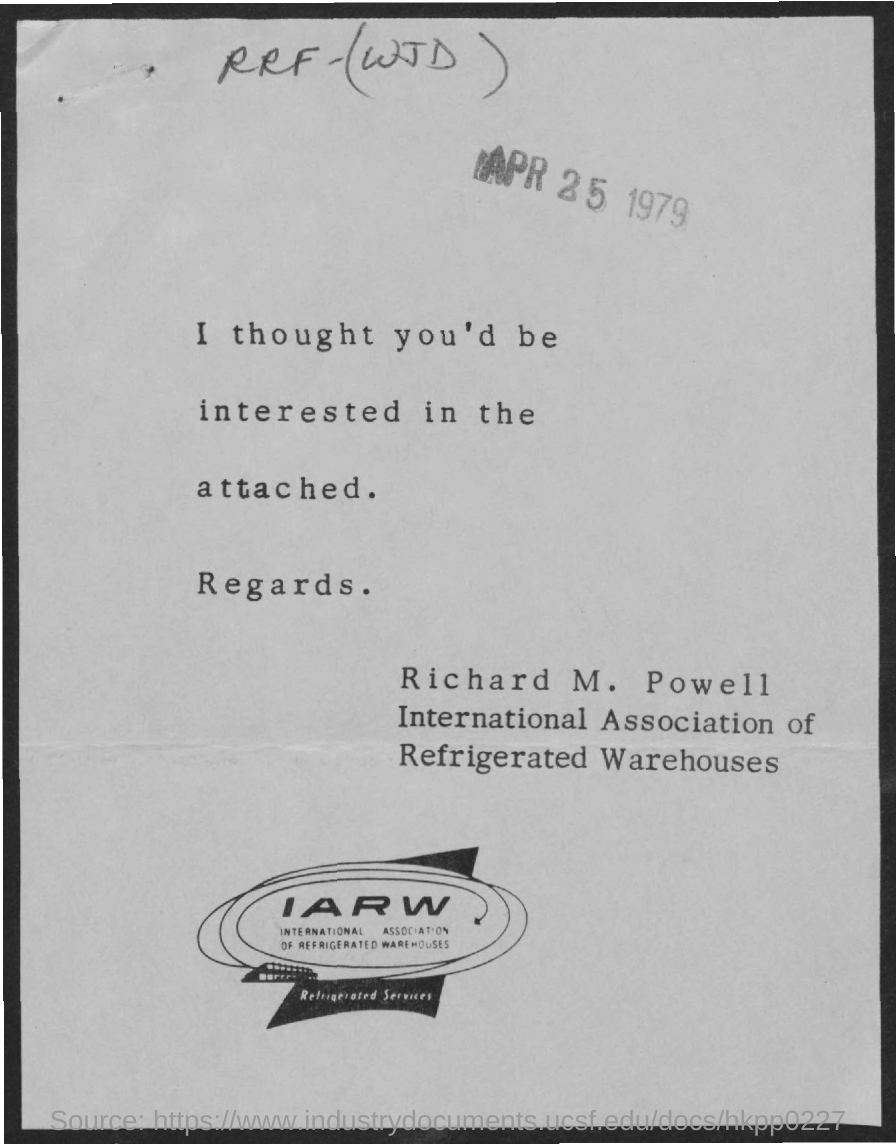List a handful of essential elements in this visual. The full form of IARW is International Association of Refrigerated Warehouses. This document is dated April 25, 1979. Richard M. Powell is a person who is affiliated with the International Association of REALTORS® with Websites (IARW). 